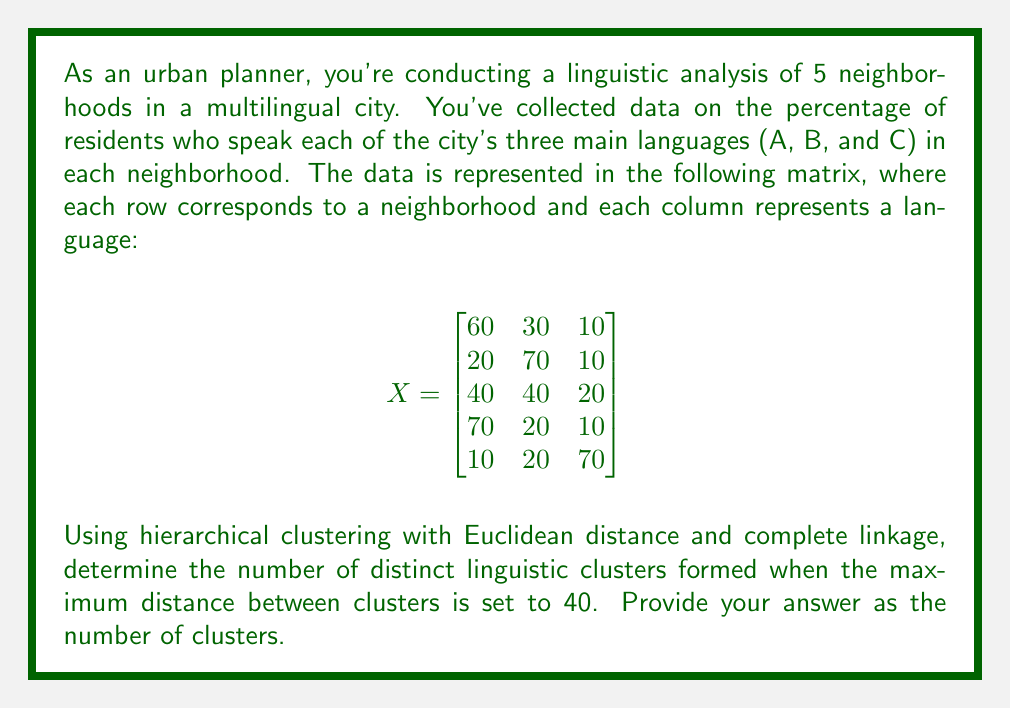Give your solution to this math problem. To solve this problem, we'll follow these steps:

1) Calculate the Euclidean distances between all pairs of neighborhoods.
2) Use complete linkage hierarchical clustering to form clusters.
3) Determine the number of clusters when the maximum distance is 40.

Step 1: Calculate Euclidean distances

For each pair of neighborhoods (i, j), we calculate:

$$d_{ij} = \sqrt{\sum_{k=1}^3 (x_{ik} - x_{jk})^2}$$

For example, for neighborhoods 1 and 2:
$$d_{12} = \sqrt{(60-20)^2 + (30-70)^2 + (10-10)^2} = \sqrt{1600 + 1600 + 0} = \sqrt{3200} \approx 56.57$$

Calculating all distances:

$$
\begin{matrix}
d_{12} \approx 56.57 & d_{13} \approx 28.28 & d_{14} \approx 14.14 & d_{15} \approx 73.48 \\
& d_{23} \approx 36.06 & d_{24} \approx 70.71 & d_{25} \approx 70.71 \\
& & d_{34} \approx 42.43 & d_{35} \approx 54.77 \\
& & & d_{45} \approx 87.18
\end{matrix}
$$

Step 2: Complete linkage clustering

We start with each neighborhood in its own cluster and iteratively merge the closest clusters. The distance between clusters is the maximum distance between their members.

1. Closest pair: (1,4), distance 14.14. Merge into cluster (1,4).
2. Next closest: (1,3) or (3,4), distance 28.28 or 42.43. Merge (1,3,4).
3. Next: (2,3), distance 36.06. But this exceeds our 40 threshold.

Step 3: Determine number of clusters

When we stop at a maximum distance of 40, we have:
- Cluster 1: Neighborhoods 1, 3, and 4
- Cluster 2: Neighborhood 2
- Cluster 3: Neighborhood 5

Therefore, we have 3 distinct linguistic clusters.
Answer: 3 clusters 